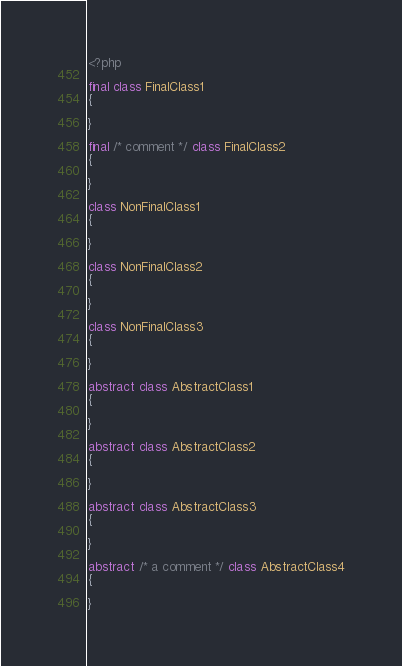Convert code to text. <code><loc_0><loc_0><loc_500><loc_500><_PHP_><?php

final class FinalClass1
{

}

final /* comment */ class FinalClass2
{

}

class NonFinalClass1
{

}

class NonFinalClass2
{

}

class NonFinalClass3
{

}

abstract class AbstractClass1
{

}

abstract class AbstractClass2
{

}

abstract class AbstractClass3
{

}

abstract /* a comment */ class AbstractClass4
{

}
</code> 